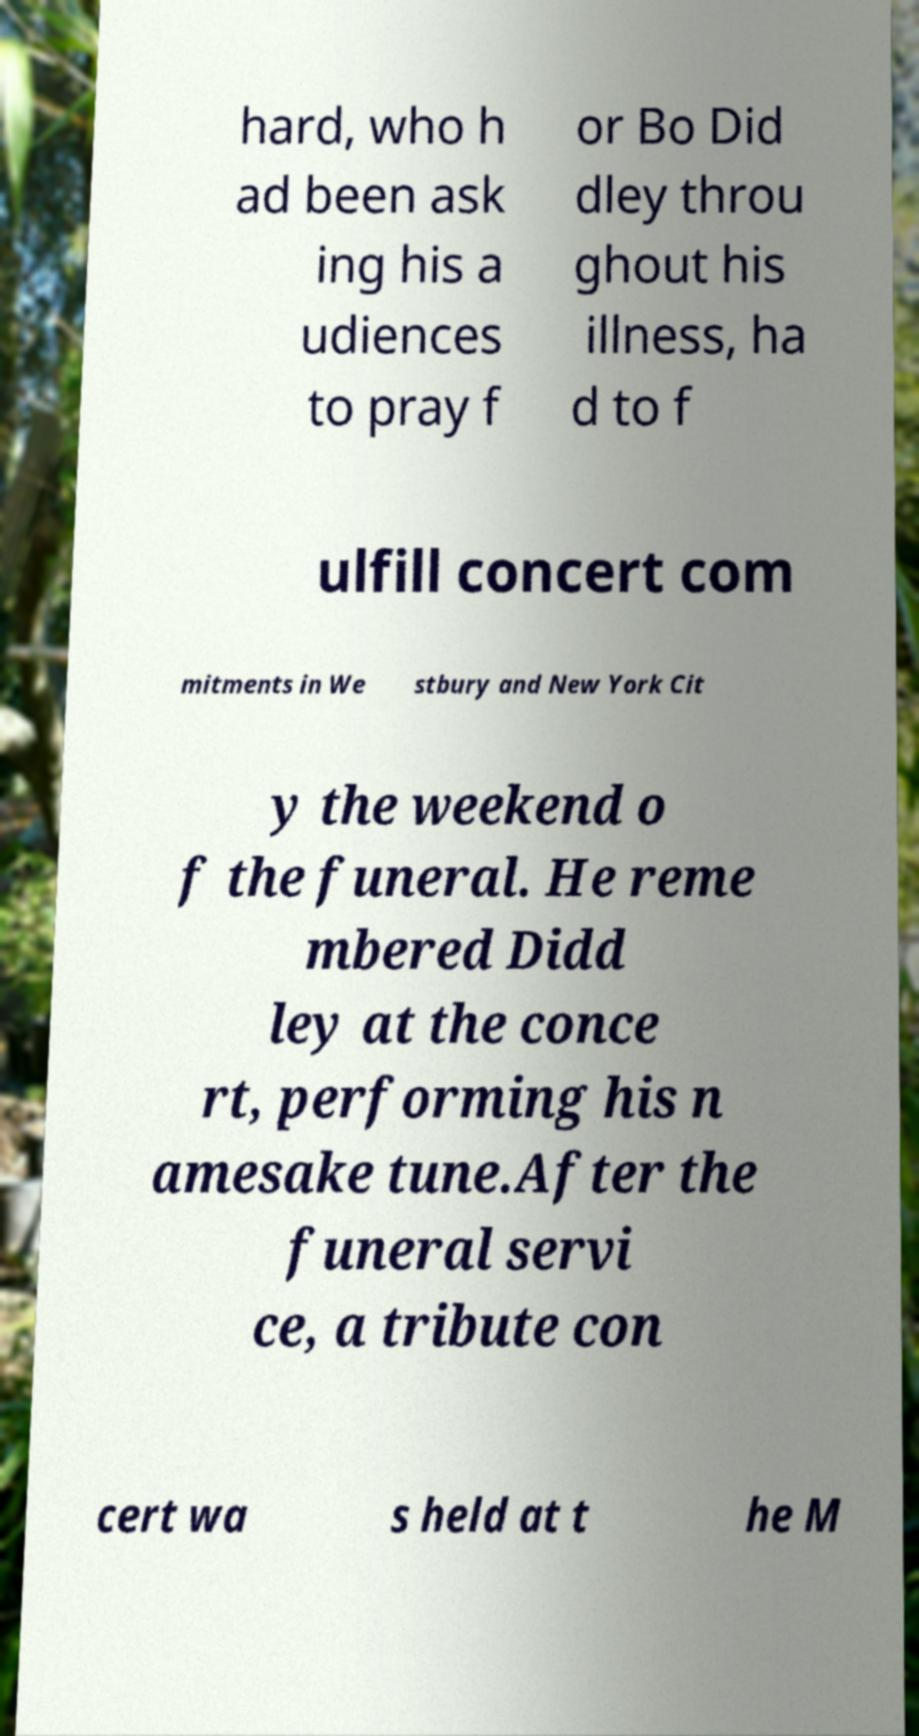For documentation purposes, I need the text within this image transcribed. Could you provide that? hard, who h ad been ask ing his a udiences to pray f or Bo Did dley throu ghout his illness, ha d to f ulfill concert com mitments in We stbury and New York Cit y the weekend o f the funeral. He reme mbered Didd ley at the conce rt, performing his n amesake tune.After the funeral servi ce, a tribute con cert wa s held at t he M 